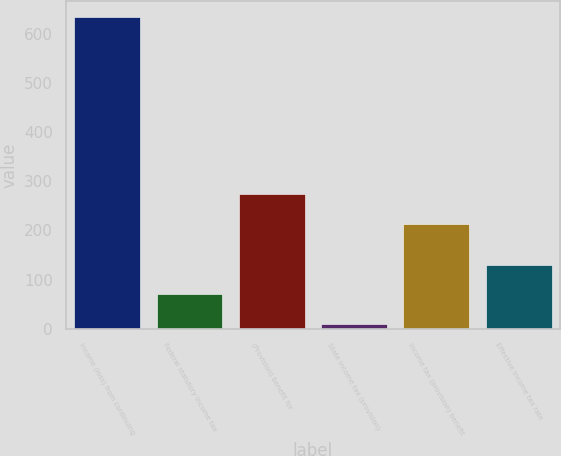<chart> <loc_0><loc_0><loc_500><loc_500><bar_chart><fcel>Income (loss) from continuing<fcel>Federal statutory income tax<fcel>(Provision) benefit for<fcel>State income tax (provision)<fcel>Income tax (provision) benefit<fcel>Effective income tax rate<nl><fcel>634.3<fcel>70.3<fcel>273.3<fcel>10<fcel>213<fcel>130.6<nl></chart> 